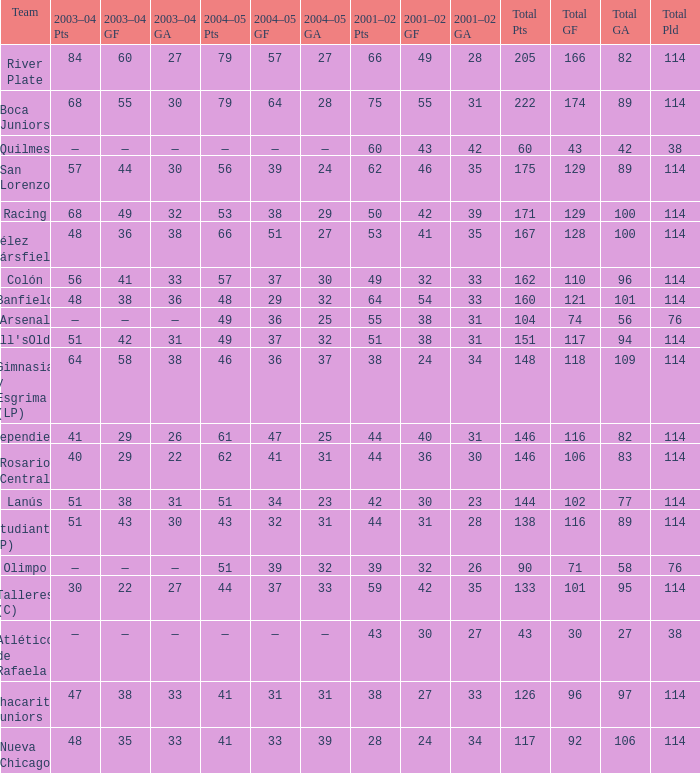Write the full table. {'header': ['Team', '2003–04 Pts', '2003–04 GF', '2003–04 GA', '2004–05 Pts', '2004–05 GF', '2004–05 GA', '2001–02 Pts', '2001–02 GF', '2001–02 GA', 'Total Pts', 'Total GF', 'Total GA', 'Total Pld'], 'rows': [['River Plate', '84', '60', '27', '79', '57', '27', '66', '49', '28', '205', '166', '82', '114'], ['Boca Juniors', '68', '55', '30', '79', '64', '28', '75', '55', '31', '222', '174', '89', '114'], ['Quilmes', '—', '—', '—', '—', '—', '—', '60', '43', '42', '60', '43', '42', '38'], ['San Lorenzo', '57', '44', '30', '56', '39', '24', '62', '46', '35', '175', '129', '89', '114'], ['Racing', '68', '49', '32', '53', '38', '29', '50', '42', '39', '171', '129', '100', '114'], ['Vélez Sársfield', '48', '36', '38', '66', '51', '27', '53', '41', '35', '167', '128', '100', '114'], ['Colón', '56', '41', '33', '57', '37', '30', '49', '32', '33', '162', '110', '96', '114'], ['Banfield', '48', '38', '36', '48', '29', '32', '64', '54', '33', '160', '121', '101', '114'], ['Arsenal', '—', '—', '—', '49', '36', '25', '55', '38', '31', '104', '74', '56', '76'], ["Newell'sOldBoys", '51', '42', '31', '49', '37', '32', '51', '38', '31', '151', '117', '94', '114'], ['Gimnasia y Esgrima (LP)', '64', '58', '38', '46', '36', '37', '38', '24', '34', '148', '118', '109', '114'], ['Independiente', '41', '29', '26', '61', '47', '25', '44', '40', '31', '146', '116', '82', '114'], ['Rosario Central', '40', '29', '22', '62', '41', '31', '44', '36', '30', '146', '106', '83', '114'], ['Lanús', '51', '38', '31', '51', '34', '23', '42', '30', '23', '144', '102', '77', '114'], ['Estudiantes (LP)', '51', '43', '30', '43', '32', '31', '44', '31', '28', '138', '116', '89', '114'], ['Olimpo', '—', '—', '—', '51', '39', '32', '39', '32', '26', '90', '71', '58', '76'], ['Talleres (C)', '30', '22', '27', '44', '37', '33', '59', '42', '35', '133', '101', '95', '114'], ['Atlético de Rafaela', '—', '—', '—', '—', '—', '—', '43', '30', '27', '43', '30', '27', '38'], ['Chacarita Juniors', '47', '38', '33', '41', '31', '31', '38', '27', '33', '126', '96', '97', '114'], ['Nueva Chicago', '48', '35', '33', '41', '33', '39', '28', '24', '34', '117', '92', '106', '114']]} Which Total Pts have a 2001–02 Pts smaller than 38? 117.0. 